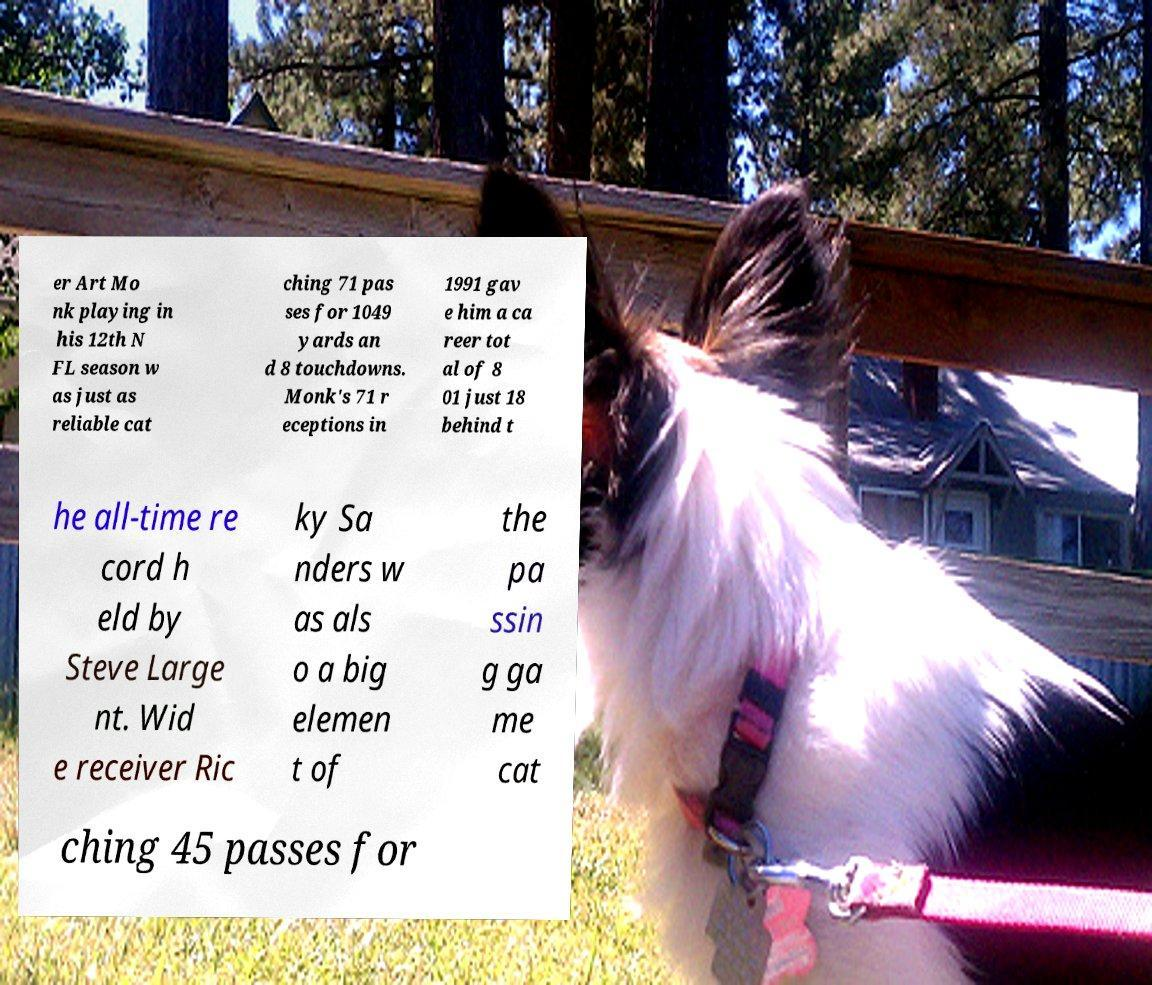Can you read and provide the text displayed in the image?This photo seems to have some interesting text. Can you extract and type it out for me? er Art Mo nk playing in his 12th N FL season w as just as reliable cat ching 71 pas ses for 1049 yards an d 8 touchdowns. Monk's 71 r eceptions in 1991 gav e him a ca reer tot al of 8 01 just 18 behind t he all-time re cord h eld by Steve Large nt. Wid e receiver Ric ky Sa nders w as als o a big elemen t of the pa ssin g ga me cat ching 45 passes for 